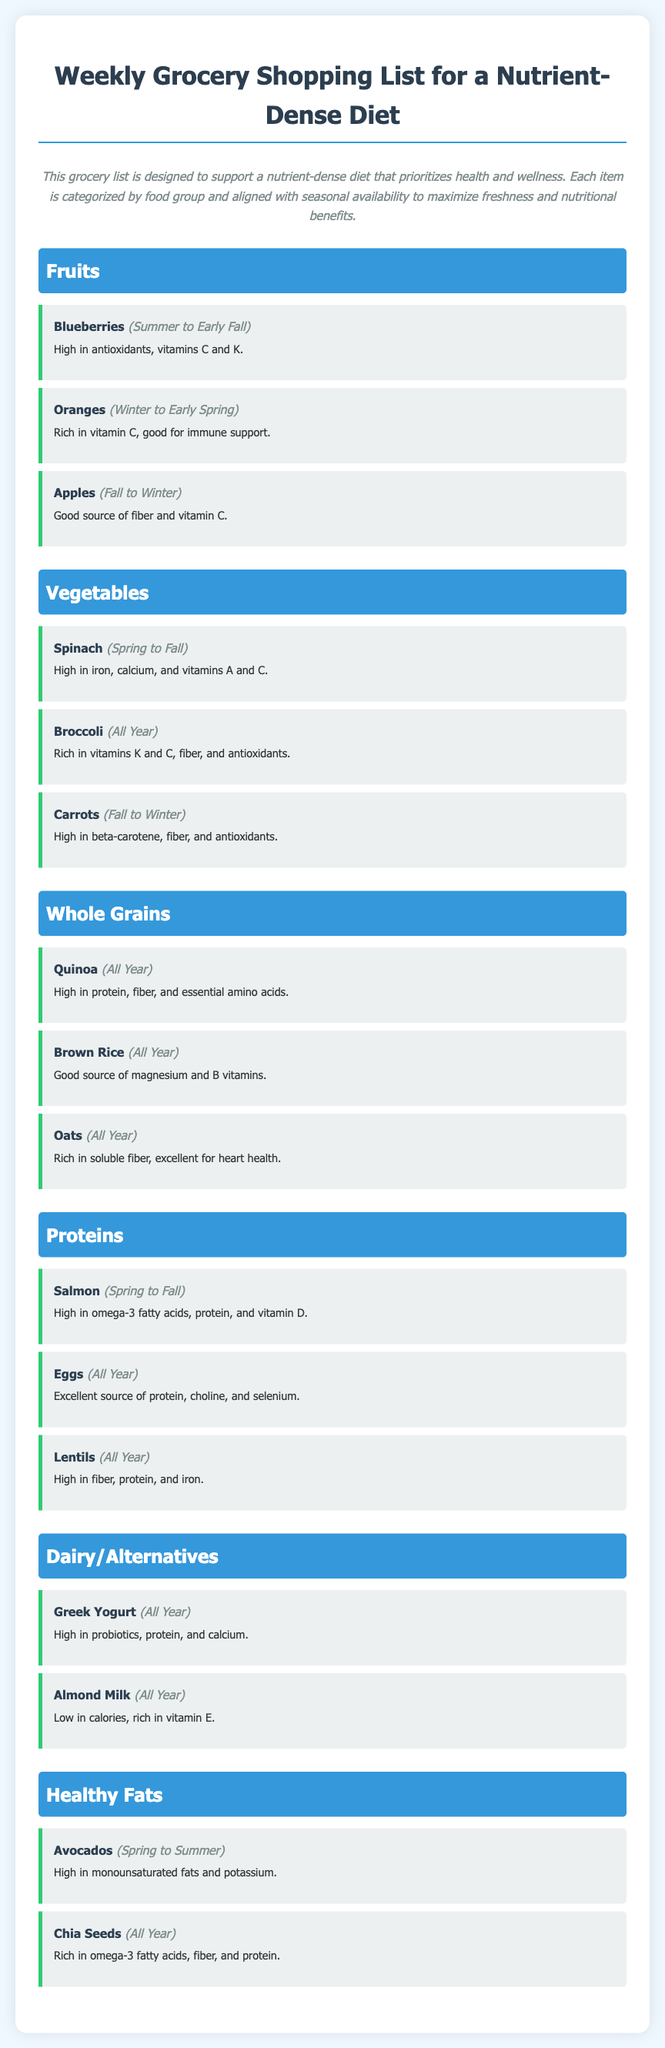What fruit is high in antioxidants? Blueberries is mentioned as high in antioxidants, vitamins C and K.
Answer: Blueberries Which vegetable is available all year round? Broccoli is noted to be available in all seasons, indicating its continuous availability.
Answer: Broccoli What is a good source of protein and omega-3 fatty acids? Salmon is specifically highlighted for being high in omega-3 fatty acids and protein.
Answer: Salmon During which season are avocados available? Avocados are listed as available from Spring to Summer, showing their seasonal availability.
Answer: Spring to Summer How many whole grain items are listed in the document? The document mentions three whole grain items, indicating their focus on diverse food options.
Answer: Three Which dairy alternative is low in calories? Almond Milk is noted for being low in calories while rich in vitamin E, making it a low-calorie option.
Answer: Almond Milk What is the main benefit of eating spinach? Spinach is noted to be high in iron, calcium, and vitamins A and C, showcasing its nutritional benefits.
Answer: High in iron, calcium, and vitamins A and C What food group includes chia seeds? The document categorizes chia seeds under Healthy Fats, aligning them with healthier food choices.
Answer: Healthy Fats What is the maximum width of the grocery list container? The document specifies that the container has a maximum width of 800 pixels, indicating its layout structure.
Answer: 800 pixels 